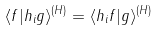Convert formula to latex. <formula><loc_0><loc_0><loc_500><loc_500>\langle f | h _ { i } g \rangle ^ { ( H ) } = \langle h _ { i } f | g \rangle ^ { ( H ) }</formula> 